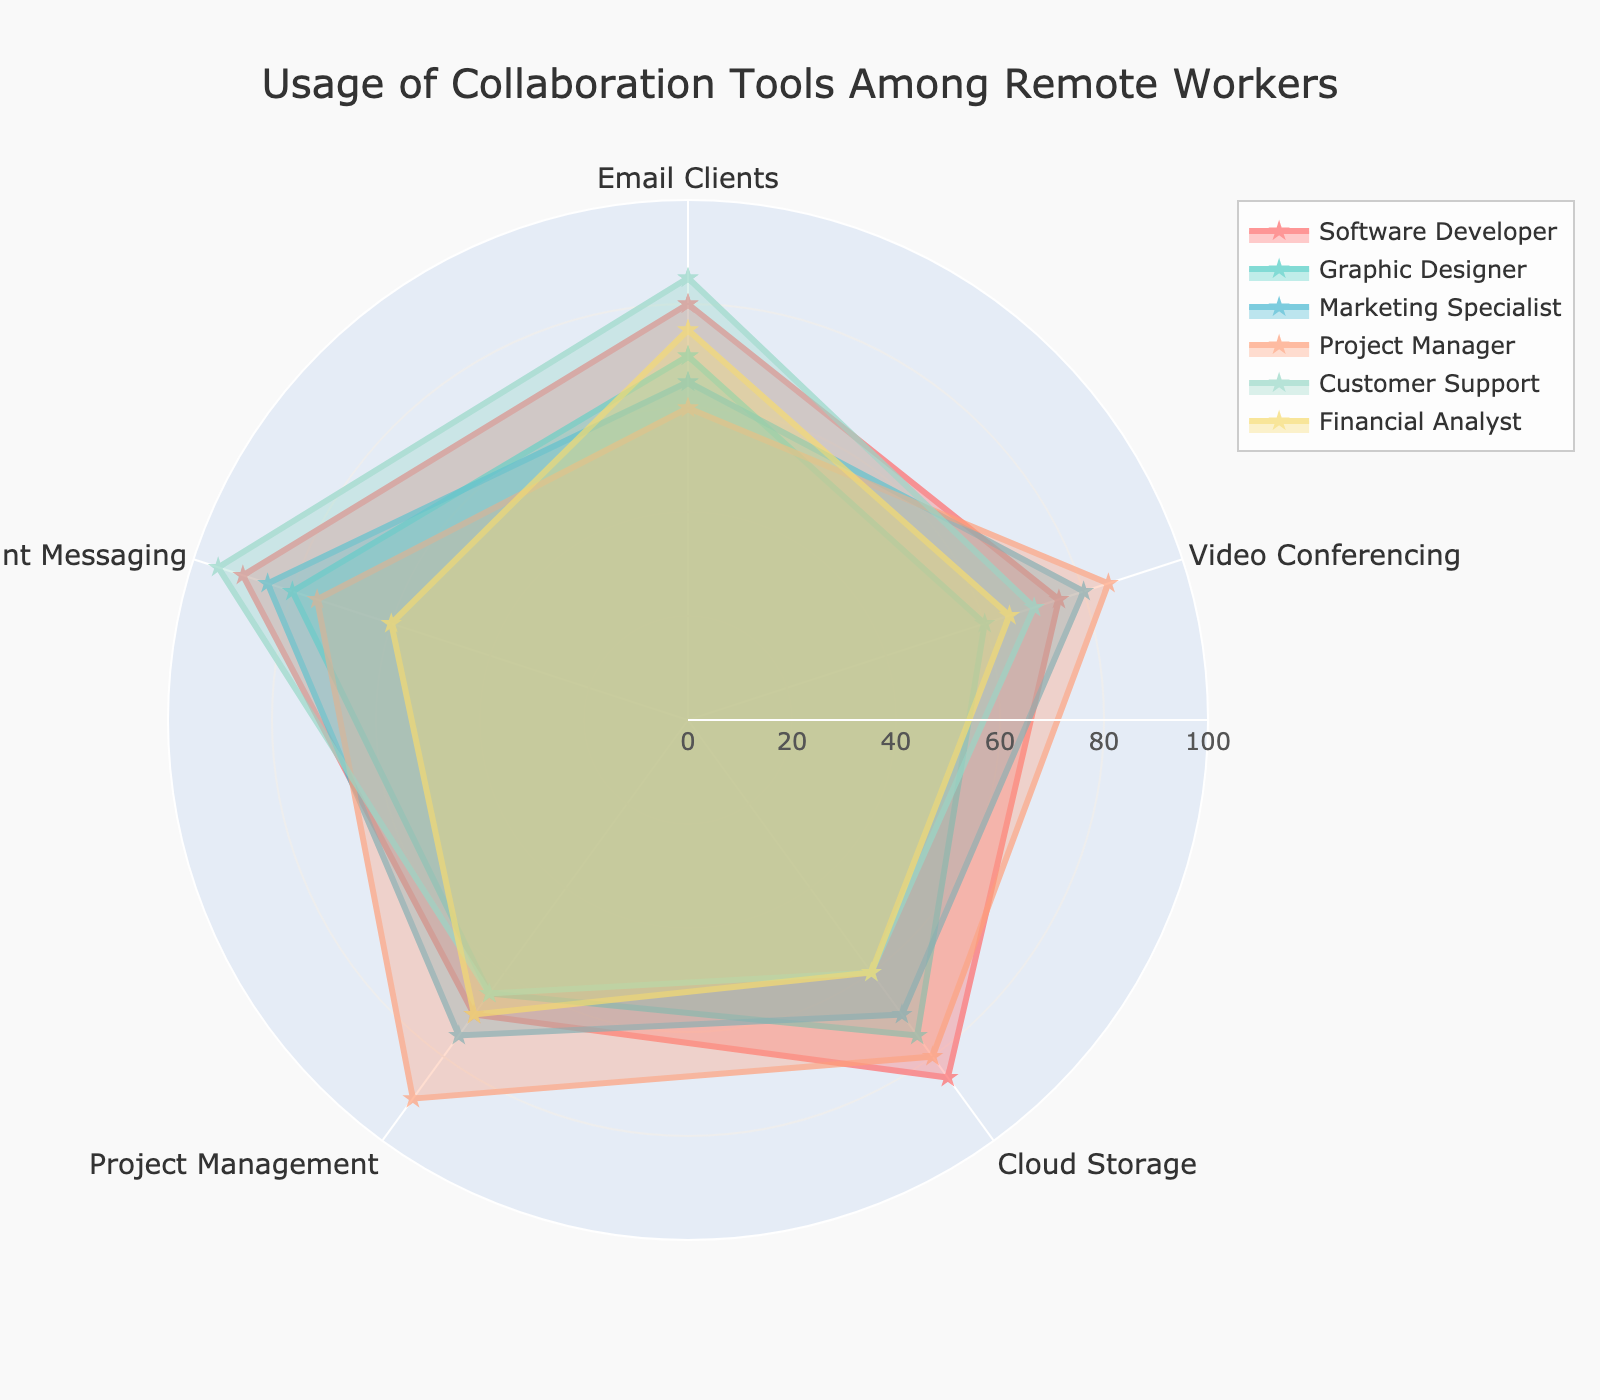What is the title of the radar chart? The title is usually displayed at the top of the chart. By looking at the top, you can see the specified title for the figure.
Answer: Usage of Collaboration Tools Among Remote Workers Which profession has the highest usage score for Instant Messaging? Look at the radial value for Instant Messaging for each profession and compare them. The profession with the highest value is the answer.
Answer: Customer Support Compare the usage scores for Video Conferencing between Software Developers and Project Managers. Who scores higher and by how much? Identify the usage score for Software Developers (75) and Project Managers (85) in the Video Conferencing category, then subtract the scores.
Answer: Project Managers by 10 What is the average usage score for Cloud Storage across all professions? Sum the usage scores for Cloud Storage from all professions and divide by the number of professions (85 + 75 + 70 + 80 + 60 + 60) / 6.
Answer: 71.67 Which profession shows the highest score across the most categories? Compare the highest scores in each category and track which profession appears most frequently as the highest.
Answer: Customer Support Which category shows the most varied usage scores among the professions? Assess each category by calculating the range (max - min) of usage scores among the professions and identify the one with the largest range.
Answer: Instant Messaging What is the unique aspect of how professions are displayed on the radar chart? Notice how each profession is represented with different visual aspects like color, marker, line opacity, etc.
Answer: Different colors and marker shapes Rank the professions based on their Project Management usage scores. Arrange the Project Management scores in descending order and list the corresponding professions.
Answer: Project Manager, Marketing Specialist, Software Developer, Financial Analyst, Graphic Designer, Customer Support Explain the variation in Email Clients usage score among the professions. How many professions have scores above 70? Examine the Email Clients scores and count the number of professions scoring above 70.
Answer: 4 Is there any profession that shows consistently lower scores across all categories? Compare the scores of each profession across all categories to identify if any profession consistently scores lower in every category.
Answer: Financial Analyst 